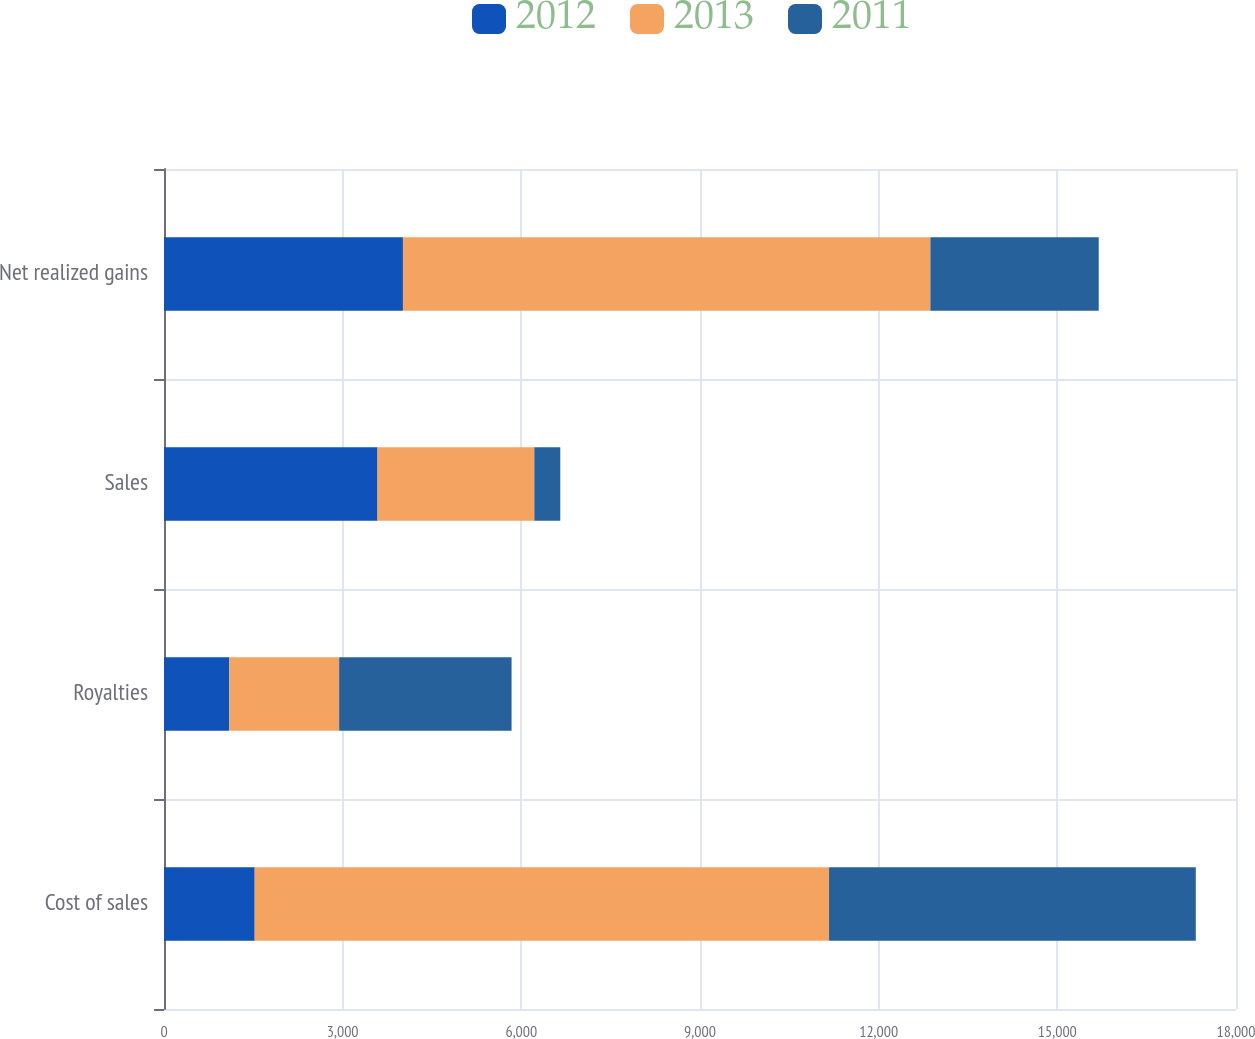Convert chart to OTSL. <chart><loc_0><loc_0><loc_500><loc_500><stacked_bar_chart><ecel><fcel>Cost of sales<fcel>Royalties<fcel>Sales<fcel>Net realized gains<nl><fcel>2012<fcel>1523<fcel>1096<fcel>3585<fcel>4012<nl><fcel>2013<fcel>9644<fcel>1845<fcel>2633<fcel>8856<nl><fcel>2011<fcel>6158<fcel>2895<fcel>436<fcel>2827<nl></chart> 